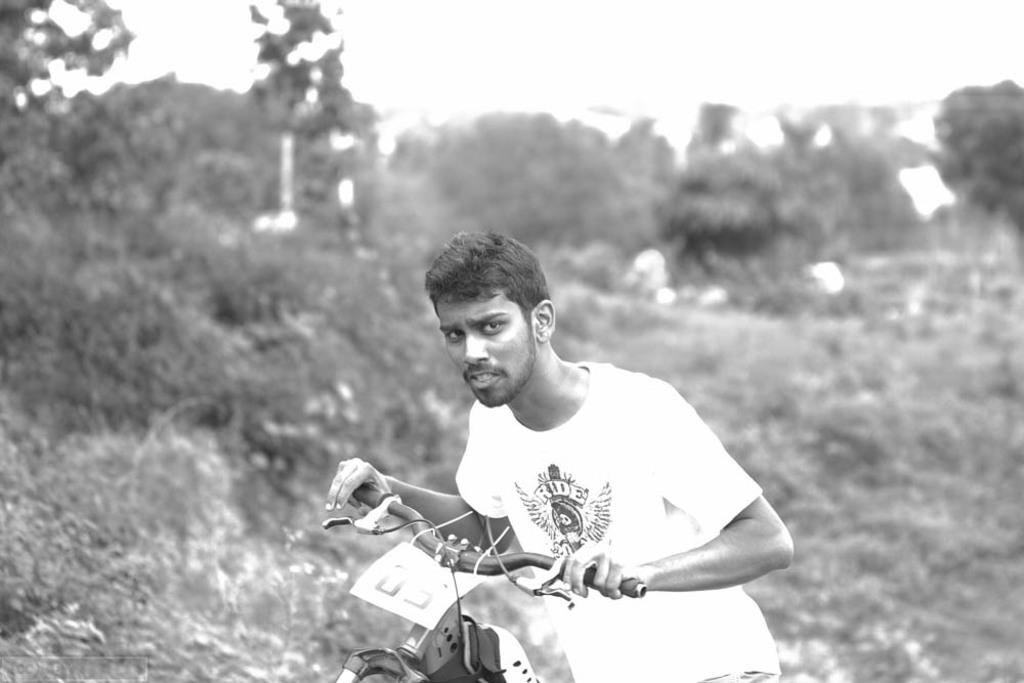What is the color scheme of the image? The image is black and white. Who is present in the image? There is a man in the image. What is the man holding in the image? The man is holding a vehicle handle. What can be seen on the vehicle in the image? There is a sticker on the vehicle. How would you describe the background of the image? The background of the image is blurry. What type of fiction is the man reading in the image? There is no book or any form of fiction present in the image. How is the distribution of the sticker on the vehicle in the image? The sticker is not being distributed in the image; it is already on the vehicle. 